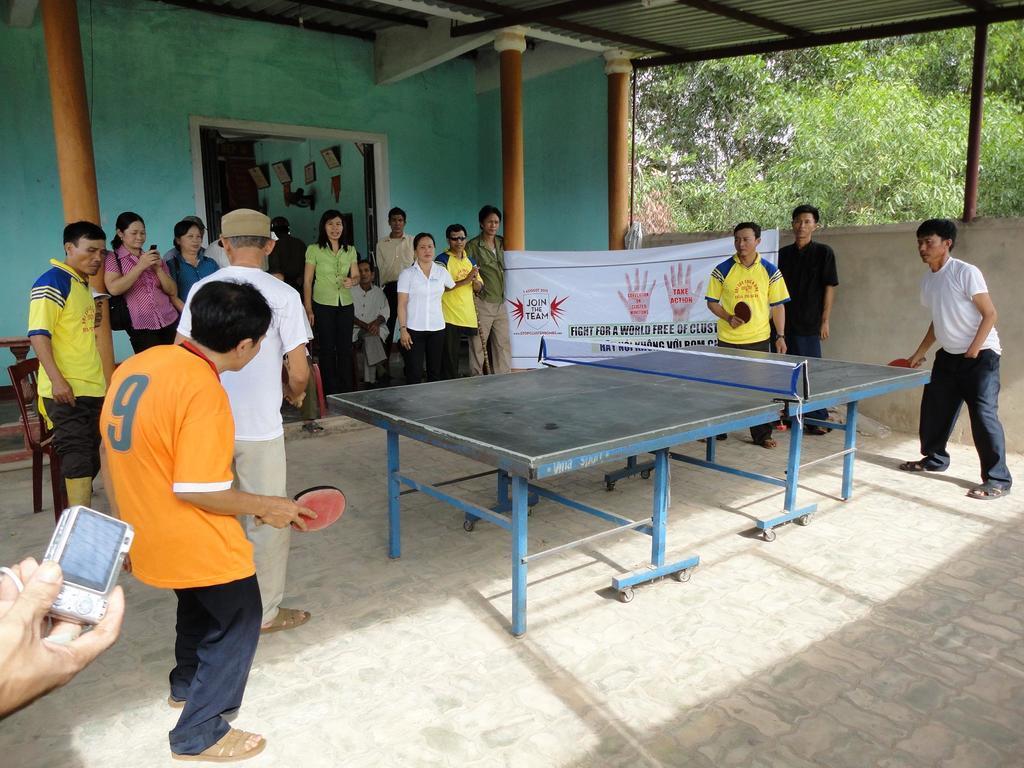Describe this image in one or two sentences. In this picture I can see the hand of a person holding a camera and there are group of people standing. There is a chair, ping pong table, banner, frames attached to the wall, and in the background there are trees and a building. 